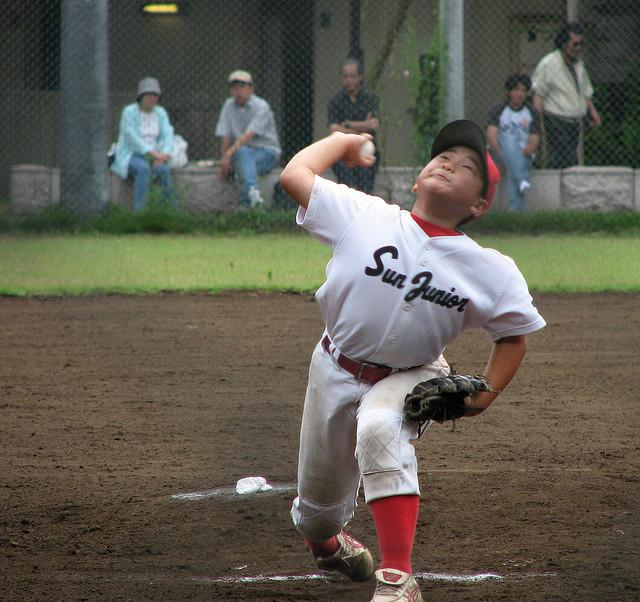Where in the world is this being played?

Choices:
A) canada
B) asia
C) africa
D) south america asia 